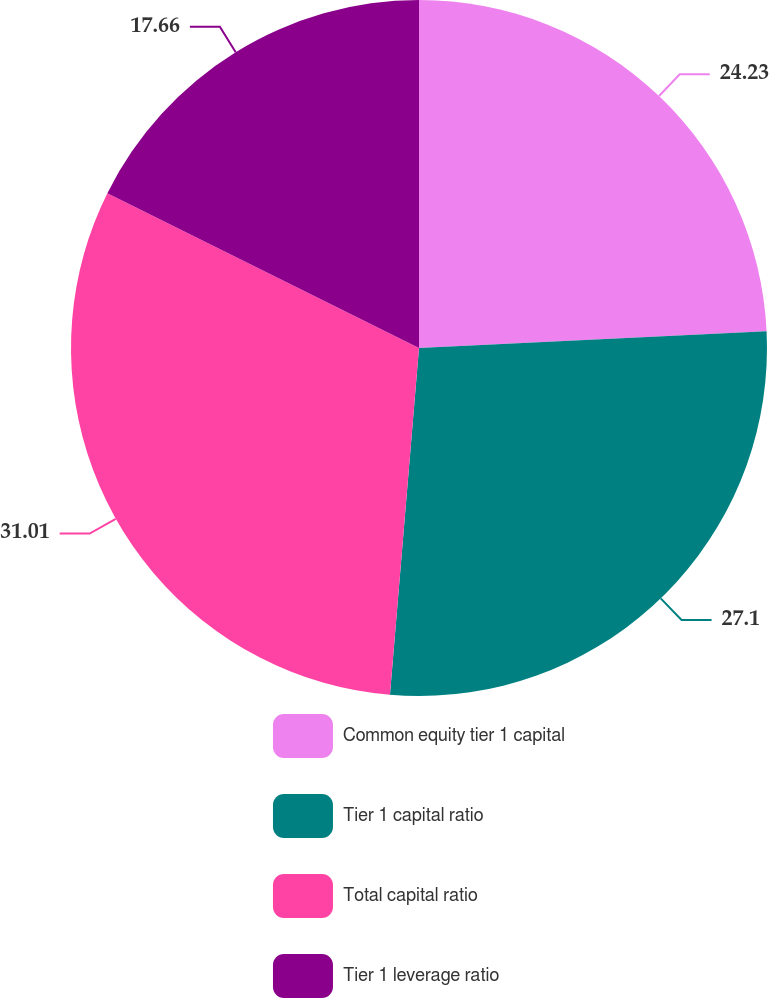<chart> <loc_0><loc_0><loc_500><loc_500><pie_chart><fcel>Common equity tier 1 capital<fcel>Tier 1 capital ratio<fcel>Total capital ratio<fcel>Tier 1 leverage ratio<nl><fcel>24.23%<fcel>27.1%<fcel>31.01%<fcel>17.66%<nl></chart> 